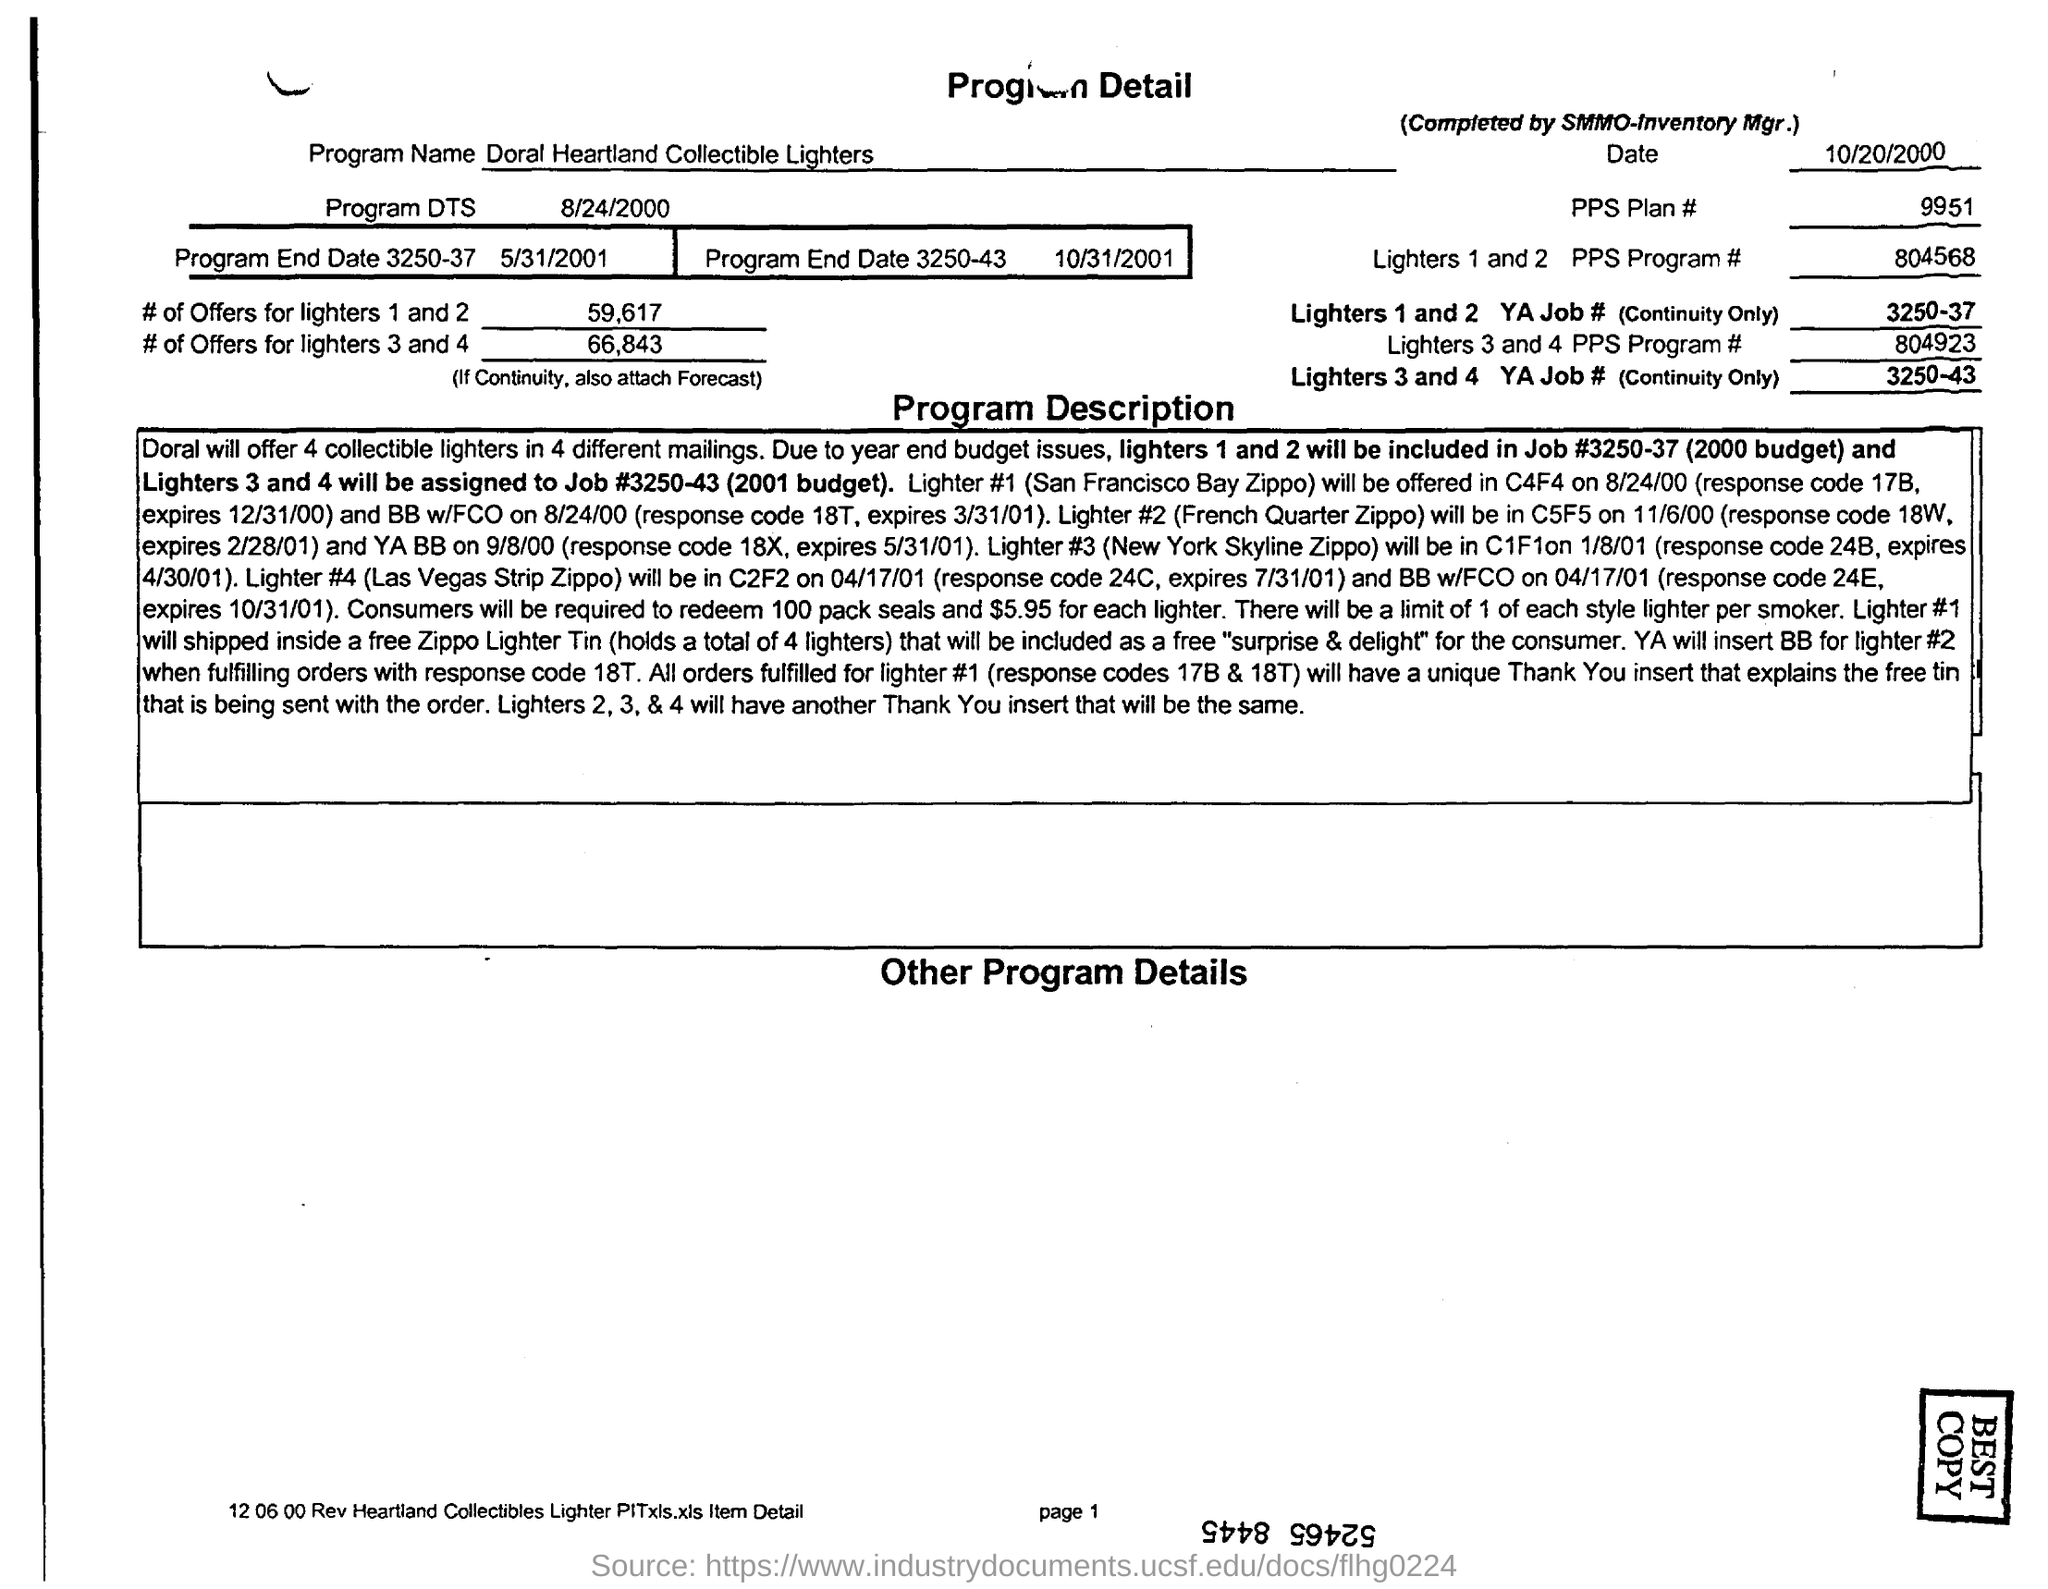What is the program name given in the product detail?
Keep it short and to the point. Doral Heartland Collectible Lighters. What is the PPS Plan no mentioned in the program detail?
Provide a short and direct response. 9951. What is the program dts mentioned in the program detail?
Give a very brief answer. 8/24/2000. What is the no of offers for lighters 1 and 2?
Your answer should be very brief. 59,617. What is the PPS program no of lighters 1 and 2?
Give a very brief answer. 804568. What is the no of offers for lighters 3 and 4?
Your response must be concise. 66,843. What is the YA Job no for Lighters 3 and 4?
Keep it short and to the point. 3250-43. What is the PPS program no of lighters 3 and 4?
Offer a terse response. 804923. 